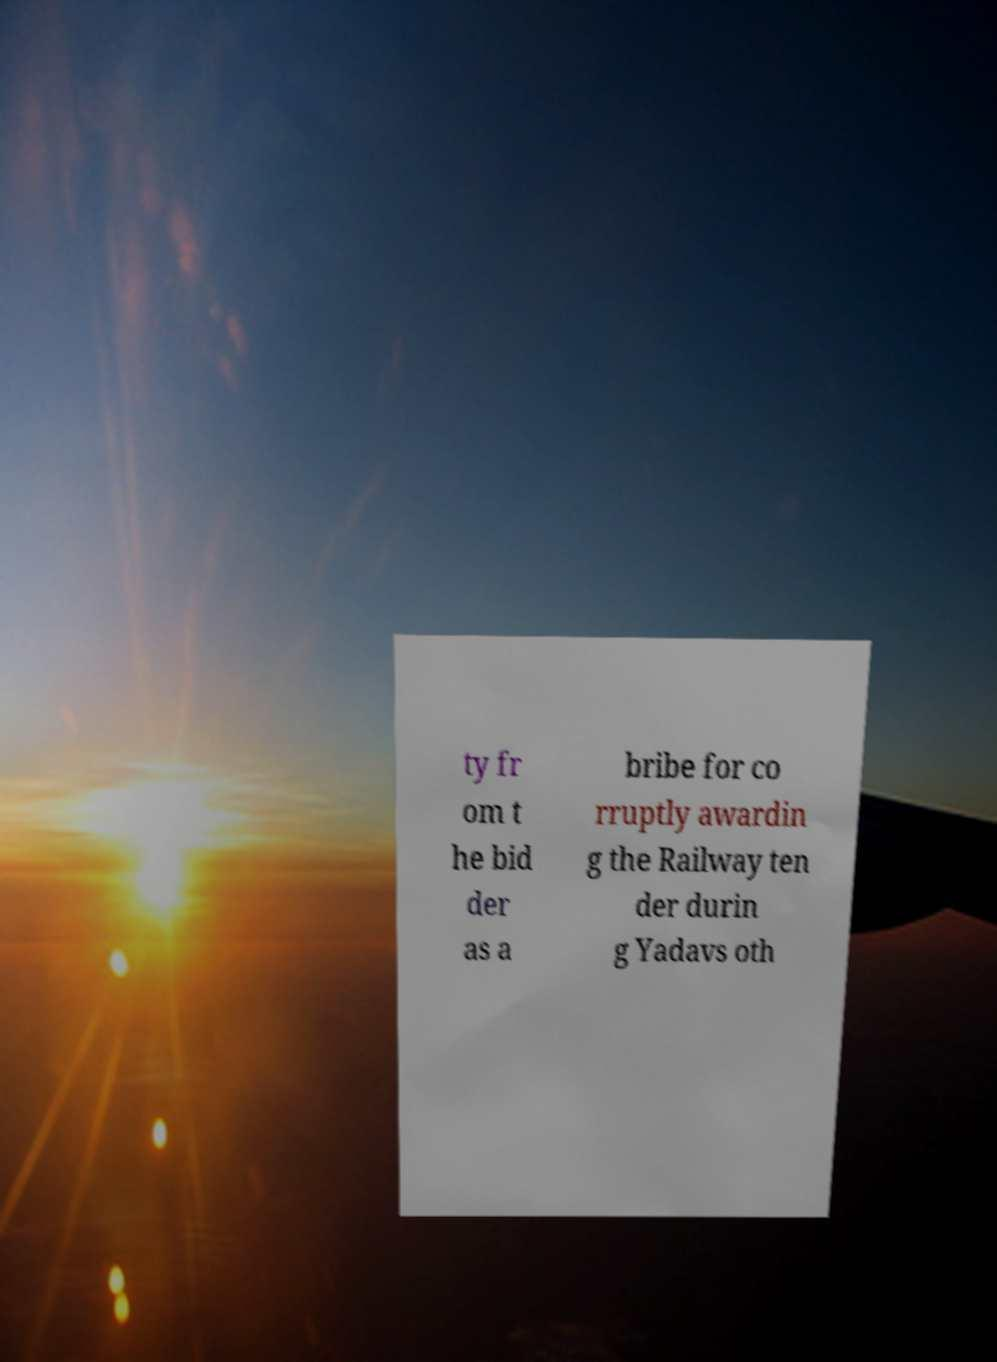Please identify and transcribe the text found in this image. ty fr om t he bid der as a bribe for co rruptly awardin g the Railway ten der durin g Yadavs oth 